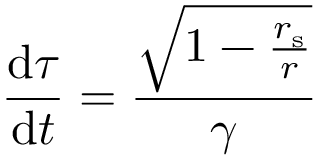Convert formula to latex. <formula><loc_0><loc_0><loc_500><loc_500>{ \frac { { d } \tau } { { d } t } } = { \frac { \sqrt { 1 - { \frac { r _ { s } } { r } } } } { \gamma } }</formula> 